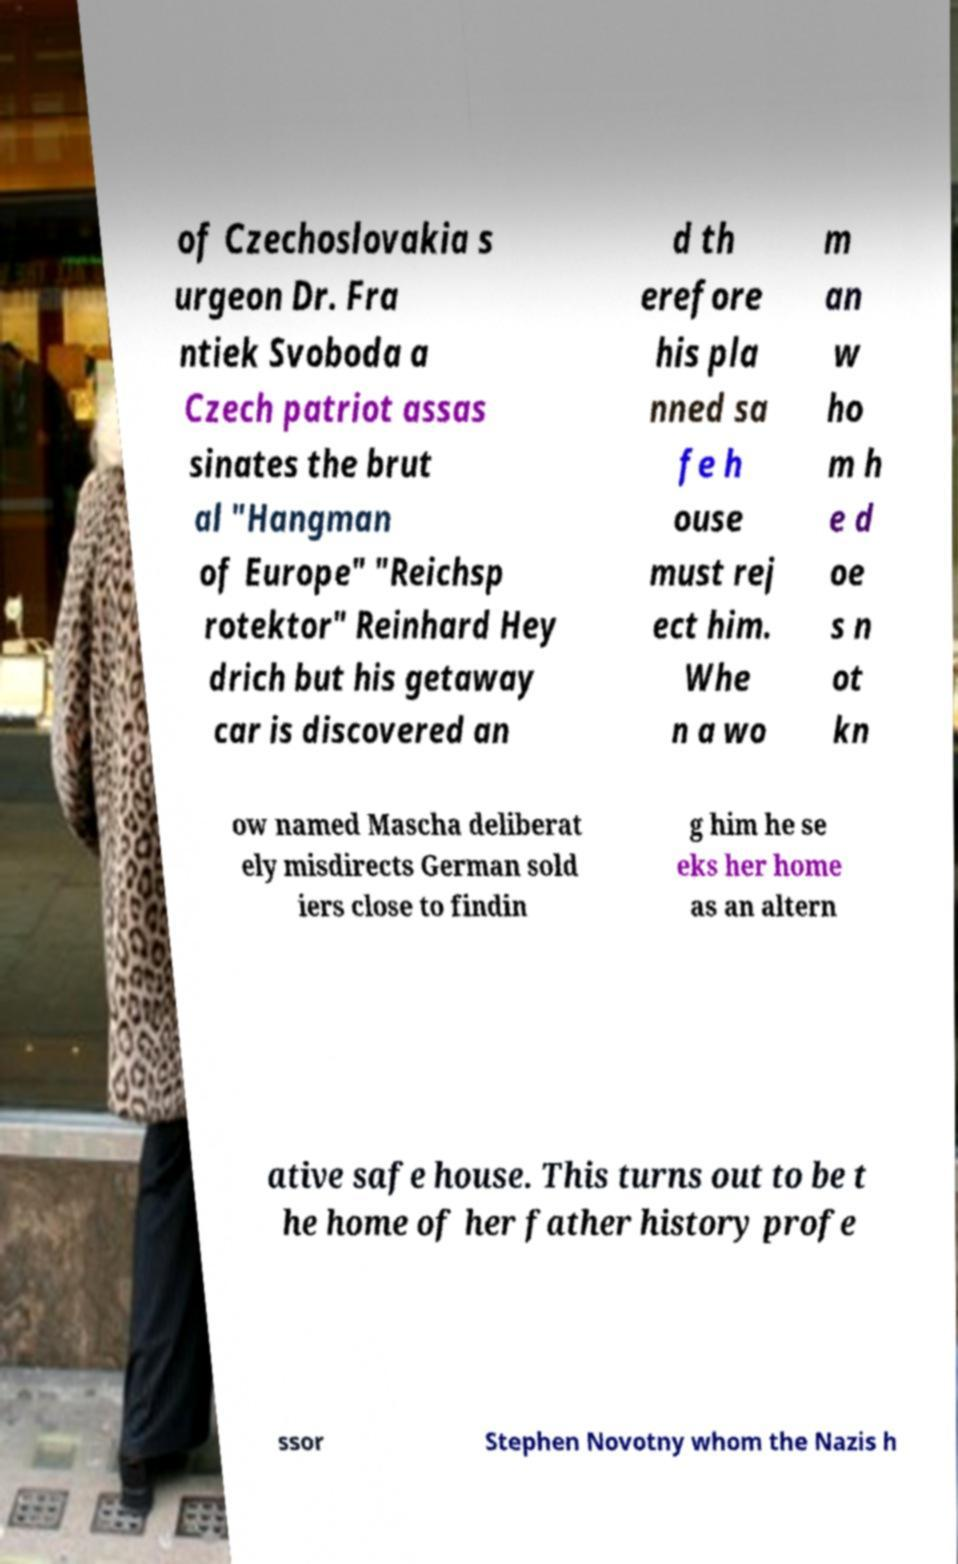For documentation purposes, I need the text within this image transcribed. Could you provide that? of Czechoslovakia s urgeon Dr. Fra ntiek Svoboda a Czech patriot assas sinates the brut al "Hangman of Europe" "Reichsp rotektor" Reinhard Hey drich but his getaway car is discovered an d th erefore his pla nned sa fe h ouse must rej ect him. Whe n a wo m an w ho m h e d oe s n ot kn ow named Mascha deliberat ely misdirects German sold iers close to findin g him he se eks her home as an altern ative safe house. This turns out to be t he home of her father history profe ssor Stephen Novotny whom the Nazis h 